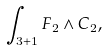<formula> <loc_0><loc_0><loc_500><loc_500>\int _ { 3 + 1 } F _ { 2 } \wedge C _ { 2 } ,</formula> 